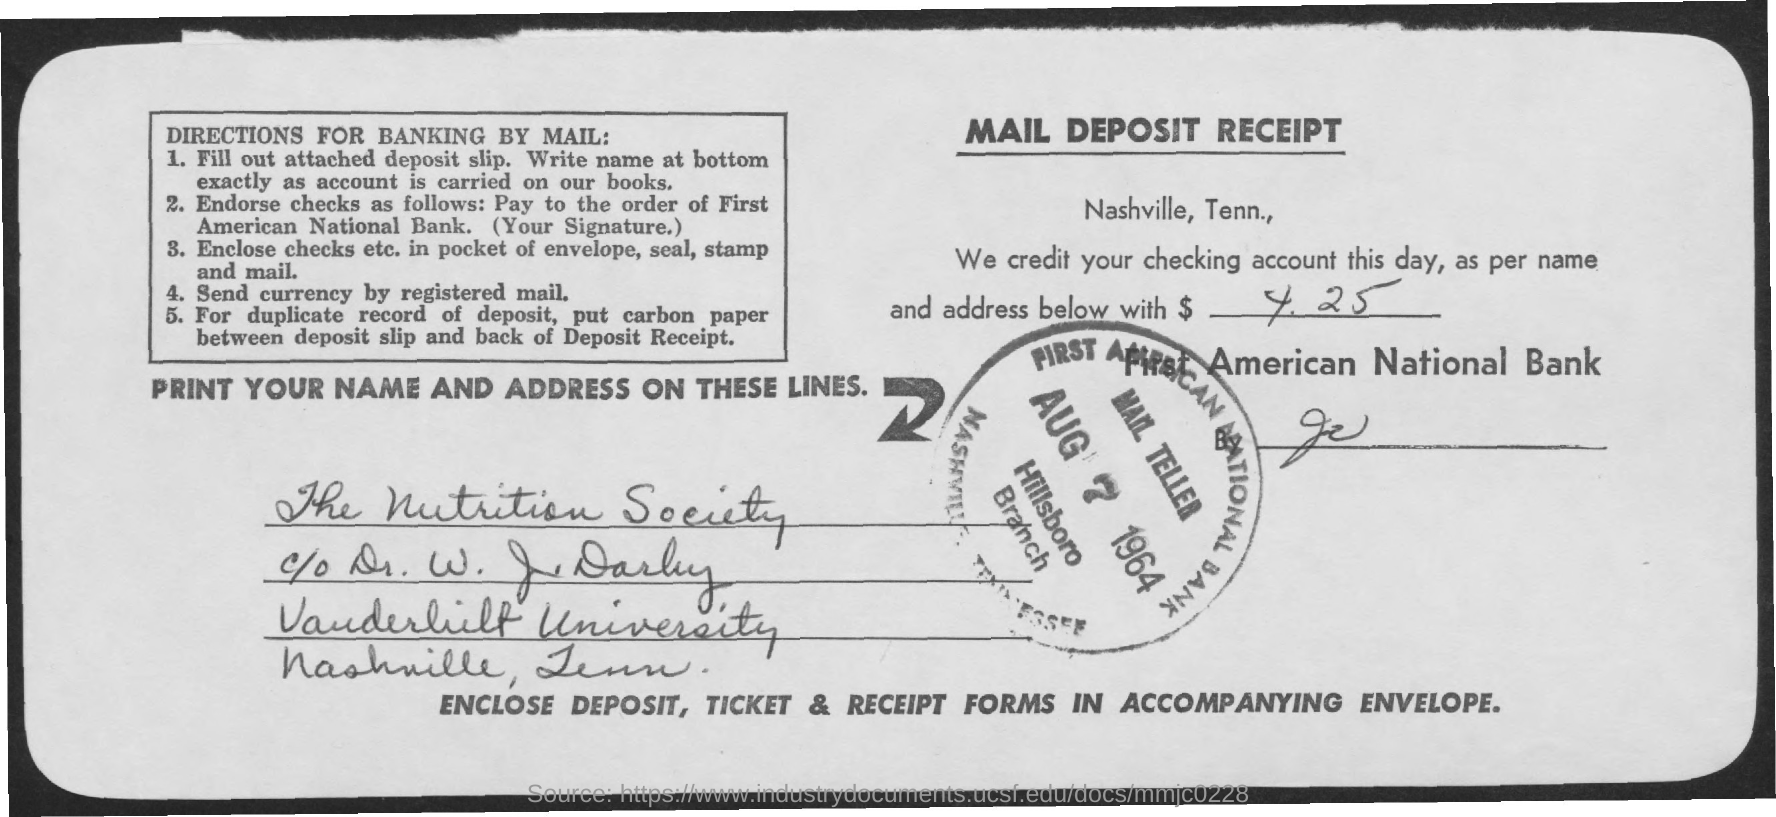Identify some key points in this picture. This is a Mail Deposit Receipt, which is a type of documentation. The date on the stamp is August 7, 1964. The amount credited to the checking account is $425. First American National Bank is mentioned in the text. 